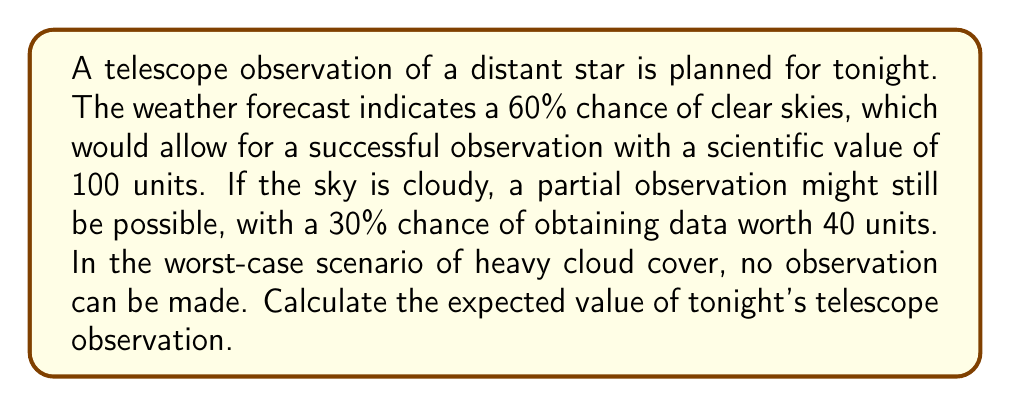Show me your answer to this math problem. Let's approach this problem step-by-step using decision theory and expected value calculations:

1) First, let's define our outcomes and their probabilities:
   - Clear skies: 60% probability (0.6)
   - Cloudy skies: 40% probability (0.4)

2) For clear skies (60% chance):
   - Value of observation: 100 units
   - Expected value: $0.6 \times 100 = 60$ units

3) For cloudy skies (40% chance):
   - 30% chance of partial observation worth 40 units
   - 70% chance of no observation (0 units)
   - Expected value for cloudy scenario: 
     $0.4 \times (0.3 \times 40 + 0.7 \times 0) = 4.8$ units

4) The total expected value is the sum of these two scenarios:

   $$ E = 60 + 4.8 = 64.8 \text{ units} $$

This calculation takes into account both the probability of different weather conditions and the potential scientific value of observations under those conditions, which is particularly relevant for an astrophysicist planning telescope observations.
Answer: The expected value of tonight's telescope observation is 64.8 units. 